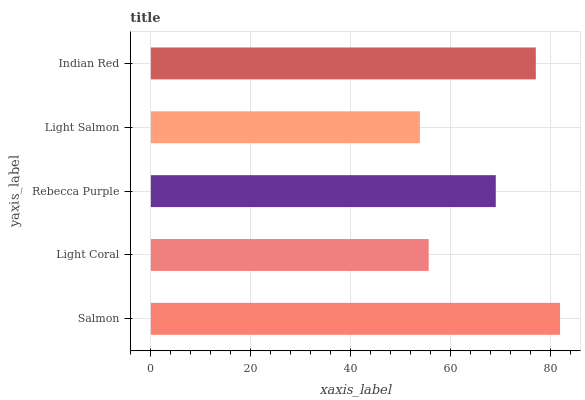Is Light Salmon the minimum?
Answer yes or no. Yes. Is Salmon the maximum?
Answer yes or no. Yes. Is Light Coral the minimum?
Answer yes or no. No. Is Light Coral the maximum?
Answer yes or no. No. Is Salmon greater than Light Coral?
Answer yes or no. Yes. Is Light Coral less than Salmon?
Answer yes or no. Yes. Is Light Coral greater than Salmon?
Answer yes or no. No. Is Salmon less than Light Coral?
Answer yes or no. No. Is Rebecca Purple the high median?
Answer yes or no. Yes. Is Rebecca Purple the low median?
Answer yes or no. Yes. Is Light Coral the high median?
Answer yes or no. No. Is Indian Red the low median?
Answer yes or no. No. 